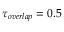<formula> <loc_0><loc_0><loc_500><loc_500>\tau _ { o v e r l a p } = 0 . 5</formula> 